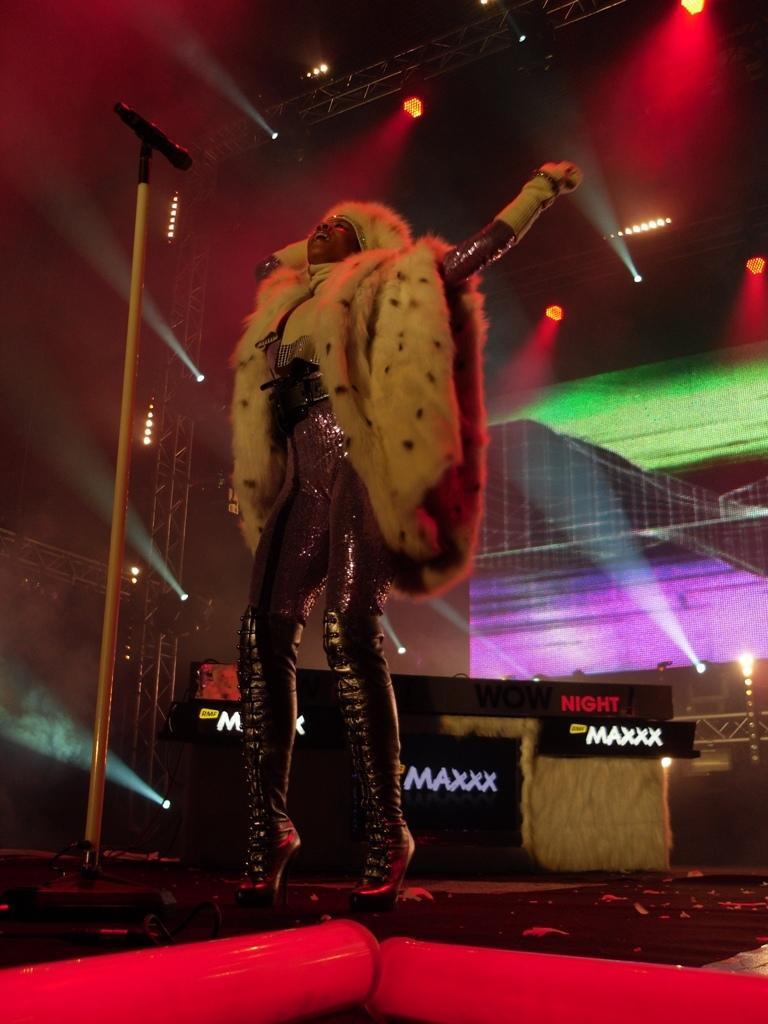Who is the main subject in the image? There is a woman in the image. What is the woman doing in the image? The woman is standing near a microphone. What can be seen at the top of the image? There are lights visible at the top of the image. Where is the scarecrow located in the image? There is no scarecrow present in the image. What activity is the boy participating in during recess in the image? There is no boy or recess depicted in the image. 